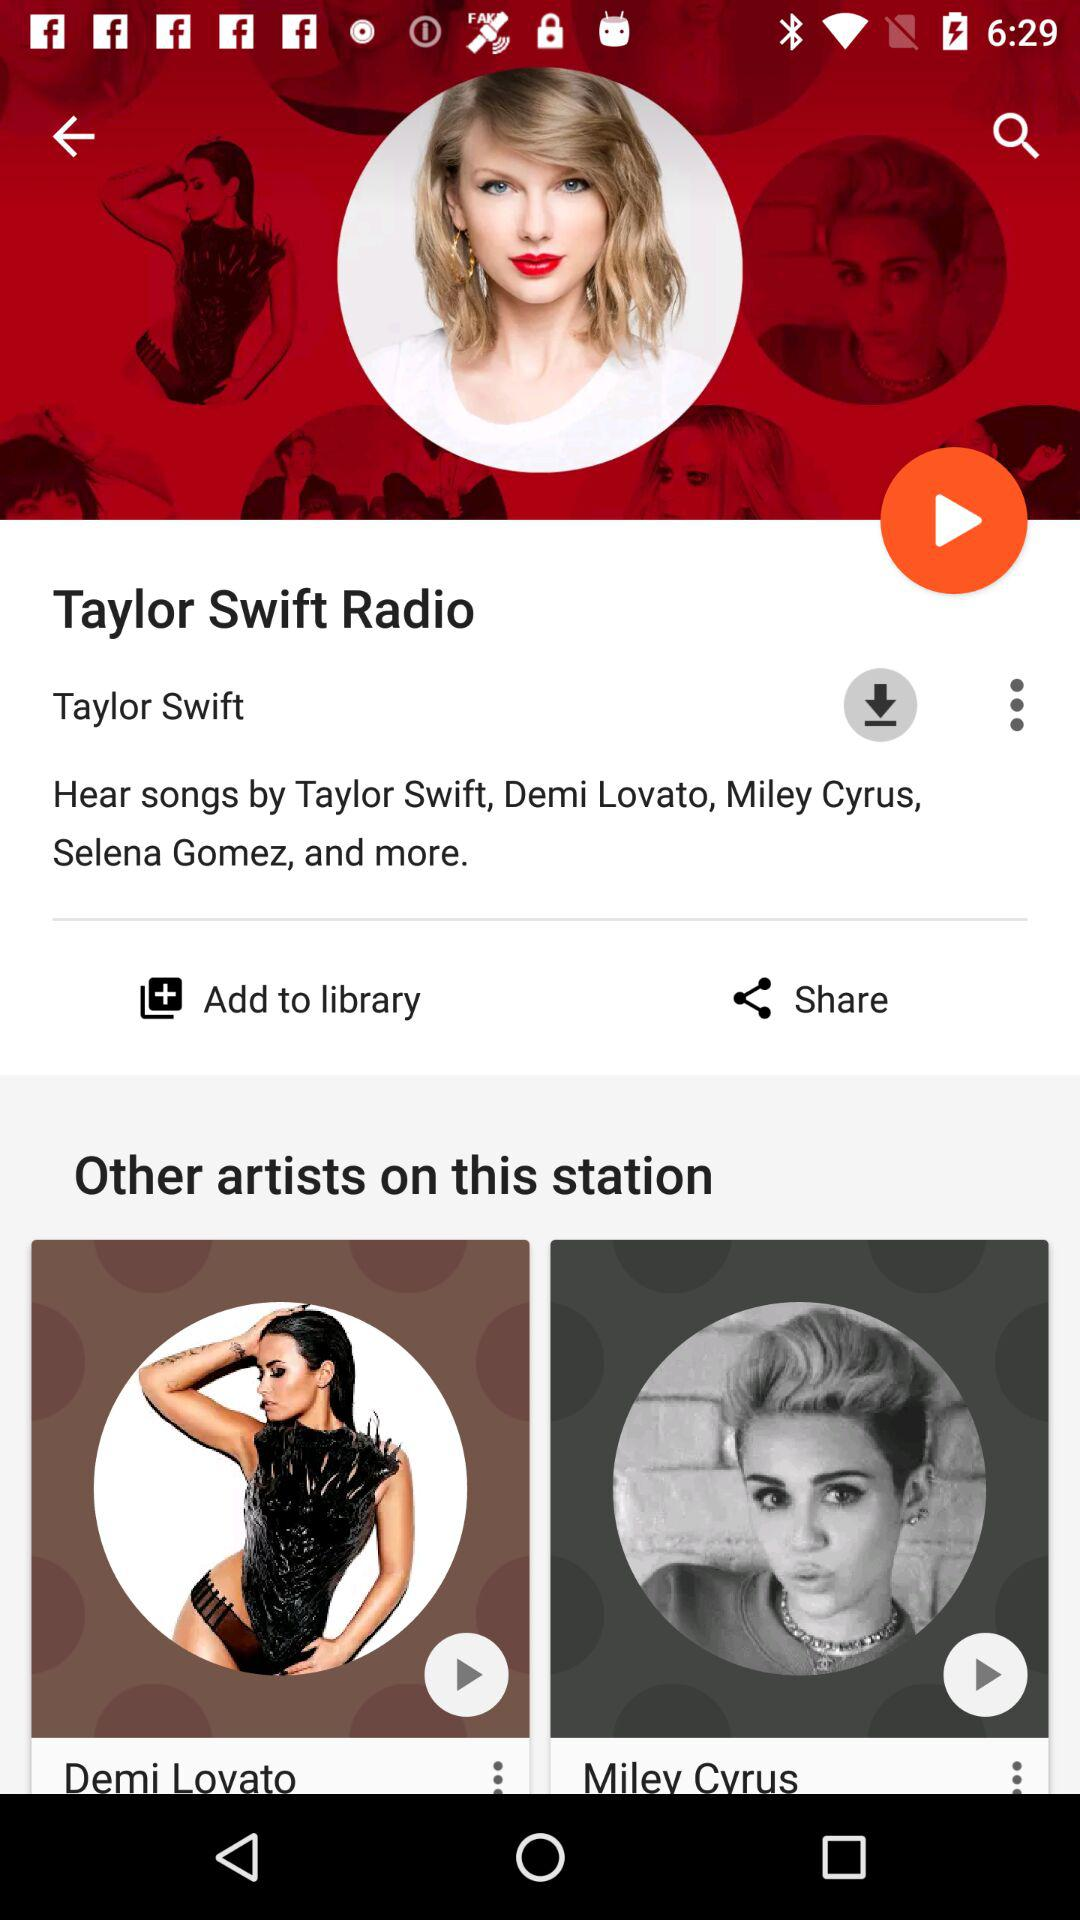How many artists are shown on this station?
Answer the question using a single word or phrase. 3 